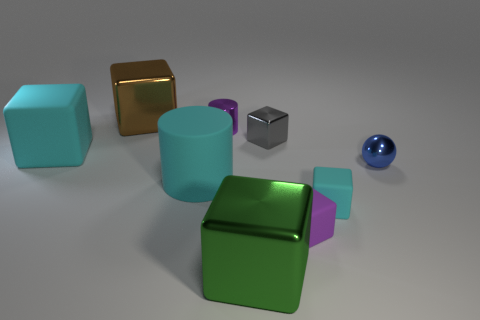Subtract all cyan rubber cubes. How many cubes are left? 4 Add 1 green objects. How many objects exist? 10 Subtract all purple cubes. How many cubes are left? 5 Subtract all cubes. How many objects are left? 3 Subtract all blue cylinders. Subtract all cyan cubes. How many cylinders are left? 2 Subtract all blue cylinders. How many cyan blocks are left? 2 Subtract all big red metallic spheres. Subtract all small purple shiny things. How many objects are left? 8 Add 1 green blocks. How many green blocks are left? 2 Add 2 small cubes. How many small cubes exist? 5 Subtract 1 purple blocks. How many objects are left? 8 